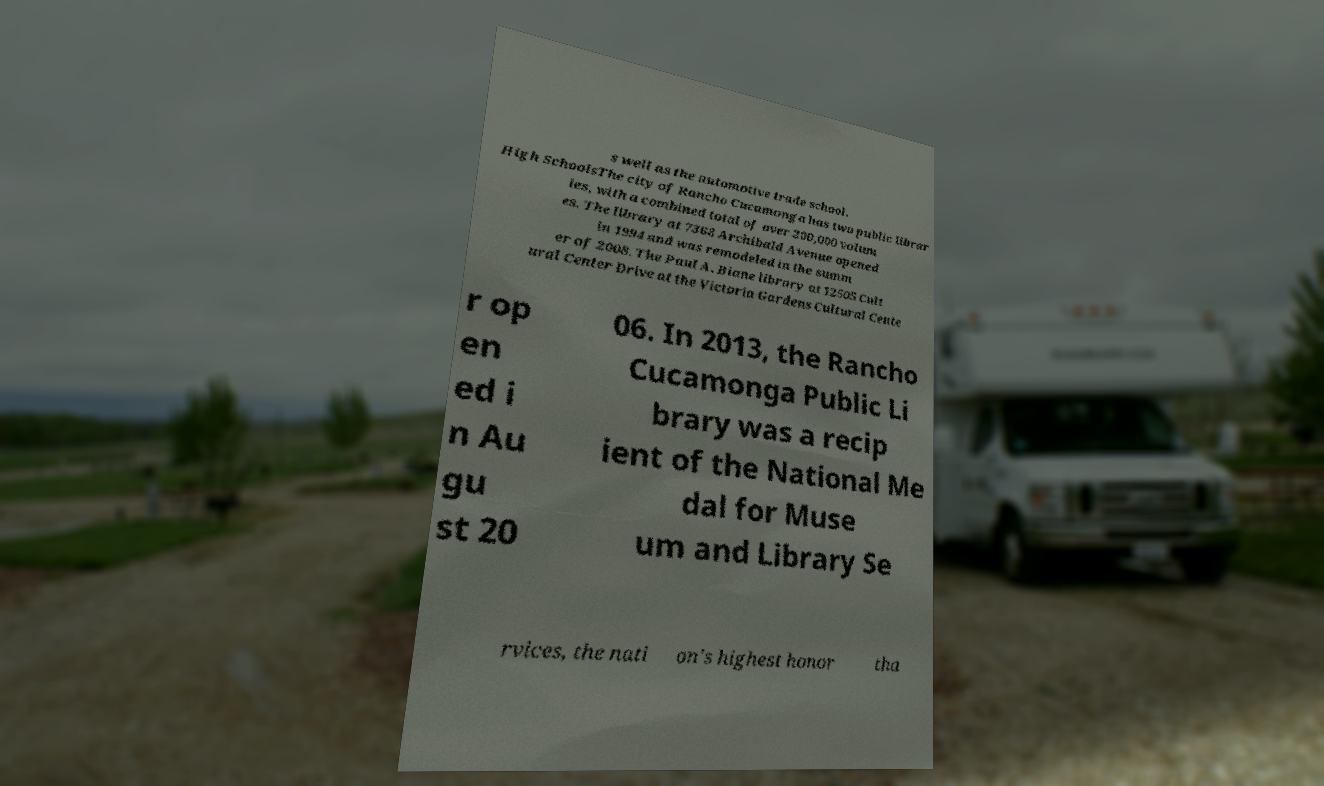Can you accurately transcribe the text from the provided image for me? s well as the automotive trade school. High SchoolsThe city of Rancho Cucamonga has two public librar ies, with a combined total of over 200,000 volum es. The library at 7368 Archibald Avenue opened in 1994 and was remodeled in the summ er of 2008. The Paul A. Biane library at 12505 Cult ural Center Drive at the Victoria Gardens Cultural Cente r op en ed i n Au gu st 20 06. In 2013, the Rancho Cucamonga Public Li brary was a recip ient of the National Me dal for Muse um and Library Se rvices, the nati on's highest honor tha 